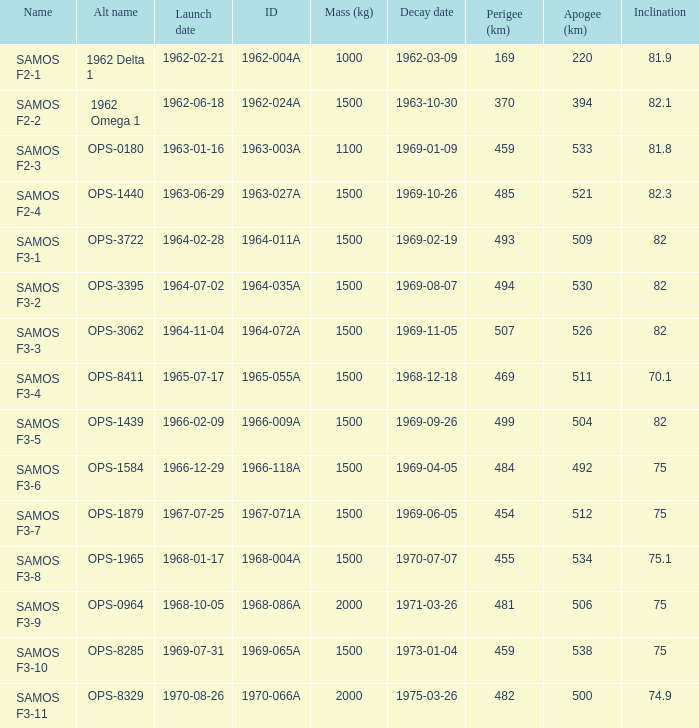What was the maximum perigee on 1969-01-09? 459.0. 